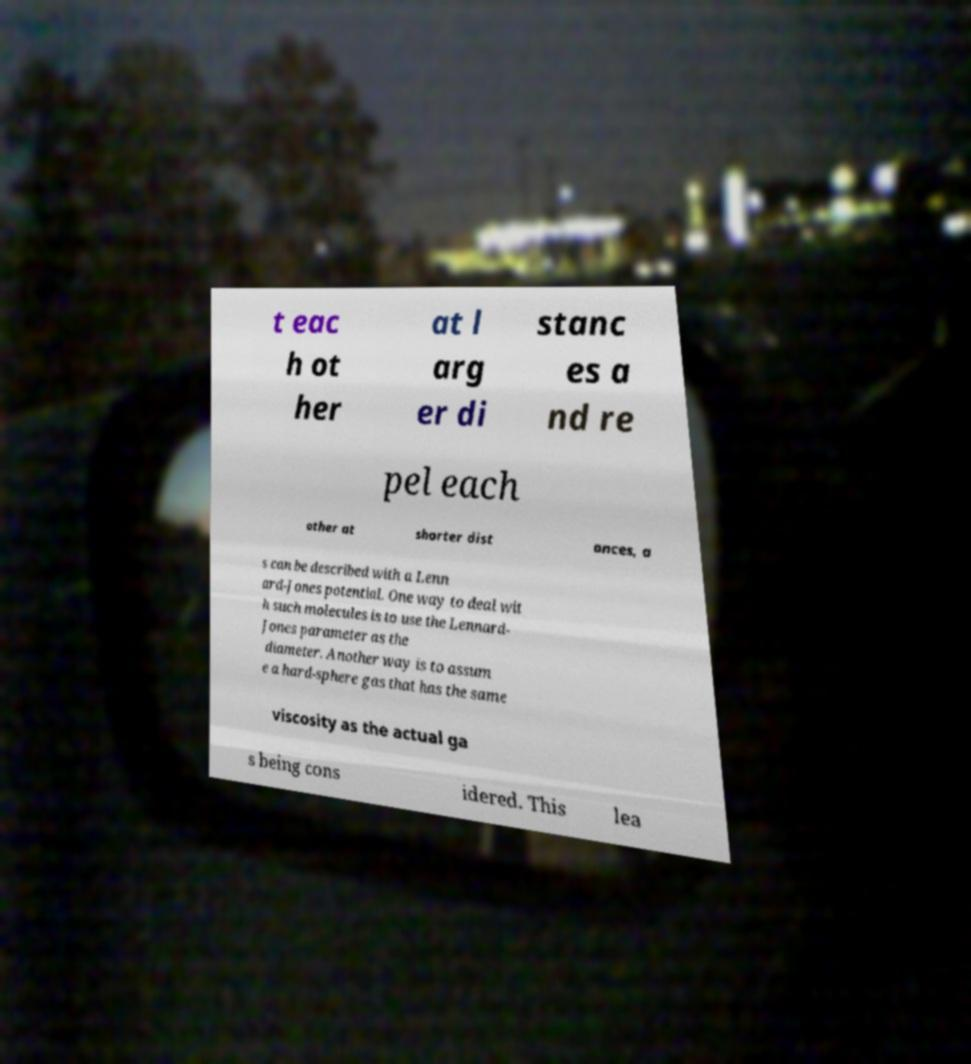There's text embedded in this image that I need extracted. Can you transcribe it verbatim? t eac h ot her at l arg er di stanc es a nd re pel each other at shorter dist ances, a s can be described with a Lenn ard-Jones potential. One way to deal wit h such molecules is to use the Lennard- Jones parameter as the diameter. Another way is to assum e a hard-sphere gas that has the same viscosity as the actual ga s being cons idered. This lea 